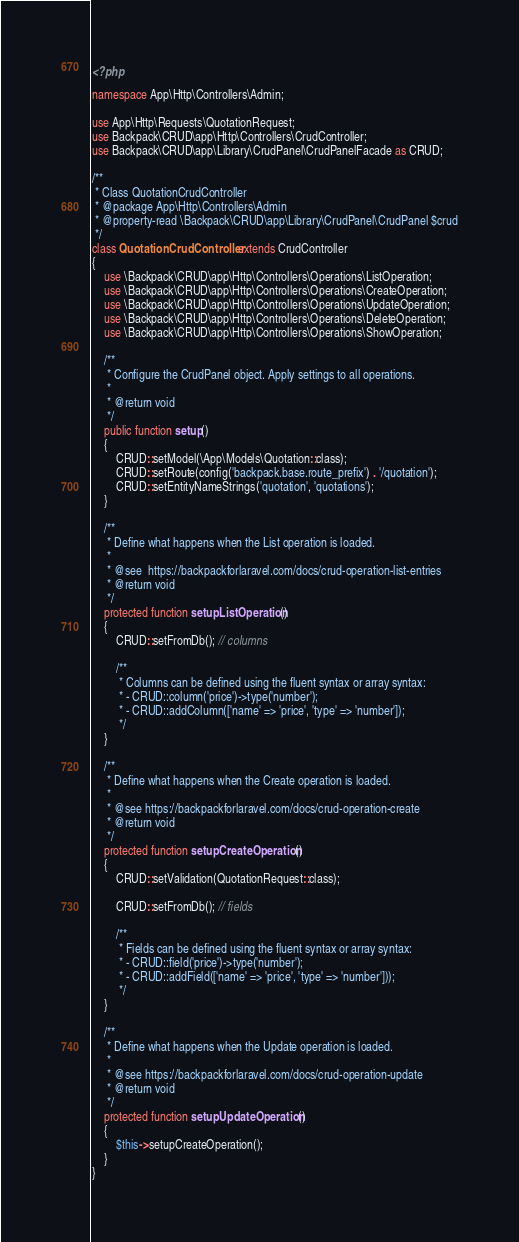Convert code to text. <code><loc_0><loc_0><loc_500><loc_500><_PHP_><?php

namespace App\Http\Controllers\Admin;

use App\Http\Requests\QuotationRequest;
use Backpack\CRUD\app\Http\Controllers\CrudController;
use Backpack\CRUD\app\Library\CrudPanel\CrudPanelFacade as CRUD;

/**
 * Class QuotationCrudController
 * @package App\Http\Controllers\Admin
 * @property-read \Backpack\CRUD\app\Library\CrudPanel\CrudPanel $crud
 */
class QuotationCrudController extends CrudController
{
    use \Backpack\CRUD\app\Http\Controllers\Operations\ListOperation;
    use \Backpack\CRUD\app\Http\Controllers\Operations\CreateOperation;
    use \Backpack\CRUD\app\Http\Controllers\Operations\UpdateOperation;
    use \Backpack\CRUD\app\Http\Controllers\Operations\DeleteOperation;
    use \Backpack\CRUD\app\Http\Controllers\Operations\ShowOperation;

    /**
     * Configure the CrudPanel object. Apply settings to all operations.
     *
     * @return void
     */
    public function setup()
    {
        CRUD::setModel(\App\Models\Quotation::class);
        CRUD::setRoute(config('backpack.base.route_prefix') . '/quotation');
        CRUD::setEntityNameStrings('quotation', 'quotations');
    }

    /**
     * Define what happens when the List operation is loaded.
     *
     * @see  https://backpackforlaravel.com/docs/crud-operation-list-entries
     * @return void
     */
    protected function setupListOperation()
    {
        CRUD::setFromDb(); // columns

        /**
         * Columns can be defined using the fluent syntax or array syntax:
         * - CRUD::column('price')->type('number');
         * - CRUD::addColumn(['name' => 'price', 'type' => 'number']);
         */
    }

    /**
     * Define what happens when the Create operation is loaded.
     *
     * @see https://backpackforlaravel.com/docs/crud-operation-create
     * @return void
     */
    protected function setupCreateOperation()
    {
        CRUD::setValidation(QuotationRequest::class);

        CRUD::setFromDb(); // fields

        /**
         * Fields can be defined using the fluent syntax or array syntax:
         * - CRUD::field('price')->type('number');
         * - CRUD::addField(['name' => 'price', 'type' => 'number']));
         */
    }

    /**
     * Define what happens when the Update operation is loaded.
     *
     * @see https://backpackforlaravel.com/docs/crud-operation-update
     * @return void
     */
    protected function setupUpdateOperation()
    {
        $this->setupCreateOperation();
    }
}
</code> 